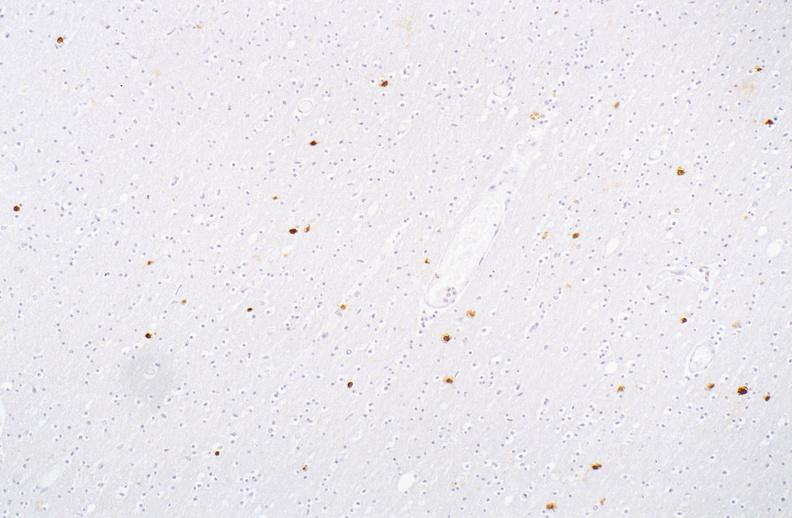does this image show herpes simplex virus, brain, immunohistochemistry?
Answer the question using a single word or phrase. Yes 